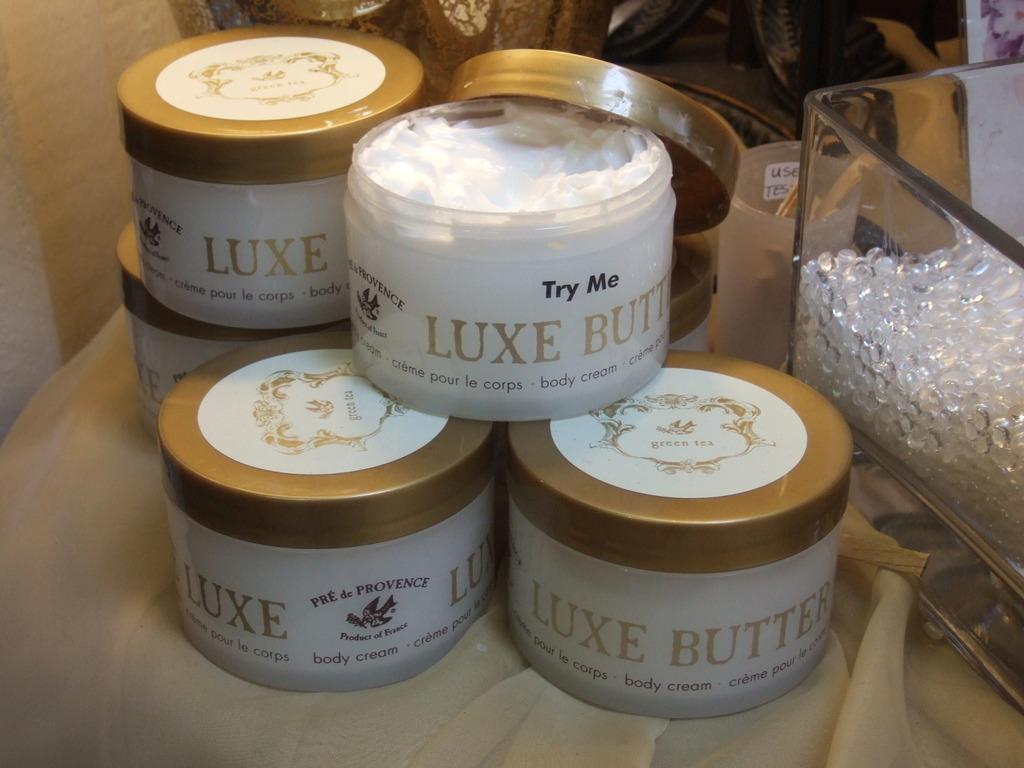What is the product called?
Make the answer very short. Luxe butter. 